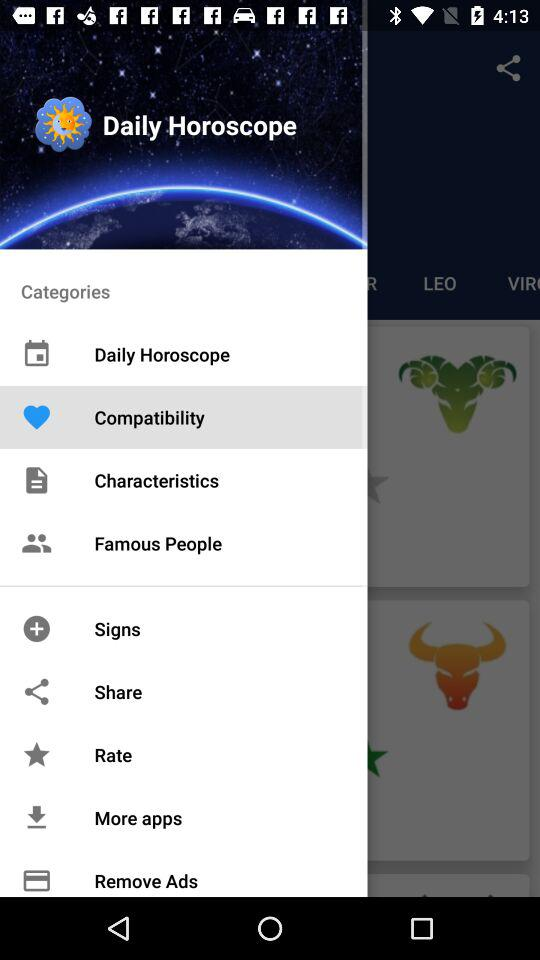What is the app name? The app name is "Daily Horoscope". 